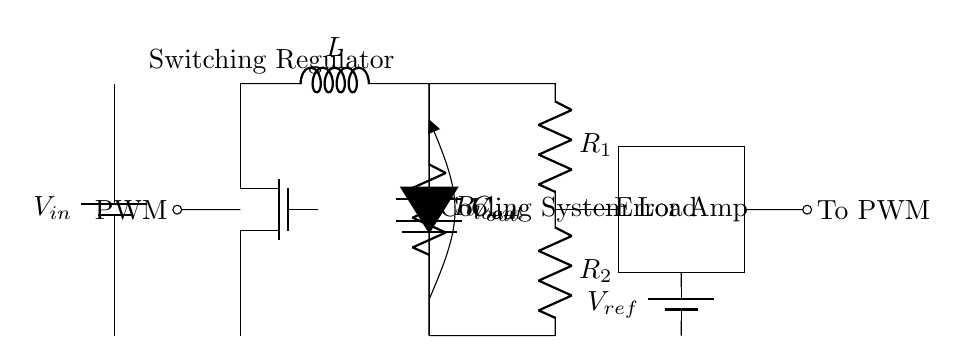What is the function of the MOSFET in this circuit? The MOSFET acts as a switch that regulates power to the load based on the PWM signal. By turning on and off rapidly, it controls the amount of energy delivered to the load.
Answer: switch What is the value of the output voltage noted in the circuit? The output voltage is marked as V out, which signifies the voltage delivered to the load.
Answer: V out What components make up the feedback network? The feedback network consists of two resistors labeled R1 and R2, which work together to provide feedback to the error amplifier from the output voltage.
Answer: R1, R2 What is the role of the error amplifier in this circuit? The error amplifier compares the reference voltage with the output voltage and adjusts the PWM signal accordingly to maintain a stable output voltage.
Answer: Error Amp Which component is used to store energy in the circuit? The inductor labeled L stores energy when the switch is closed (when the MOSFET is on) and releases it to the load when the switch is open.
Answer: L What is the purpose of the output capacitor? The output capacitor labeled C out smooths the output voltage and reduces voltage ripple, providing a stable voltage to the load during switching events.
Answer: C out How does the PWM signal affect the switching regulator's operation? The PWM signal controls the on-off time of the MOSFET, effectively adjusting the average voltage and current supplied to the load based on the cooling requirements in the server room.
Answer: PWM 